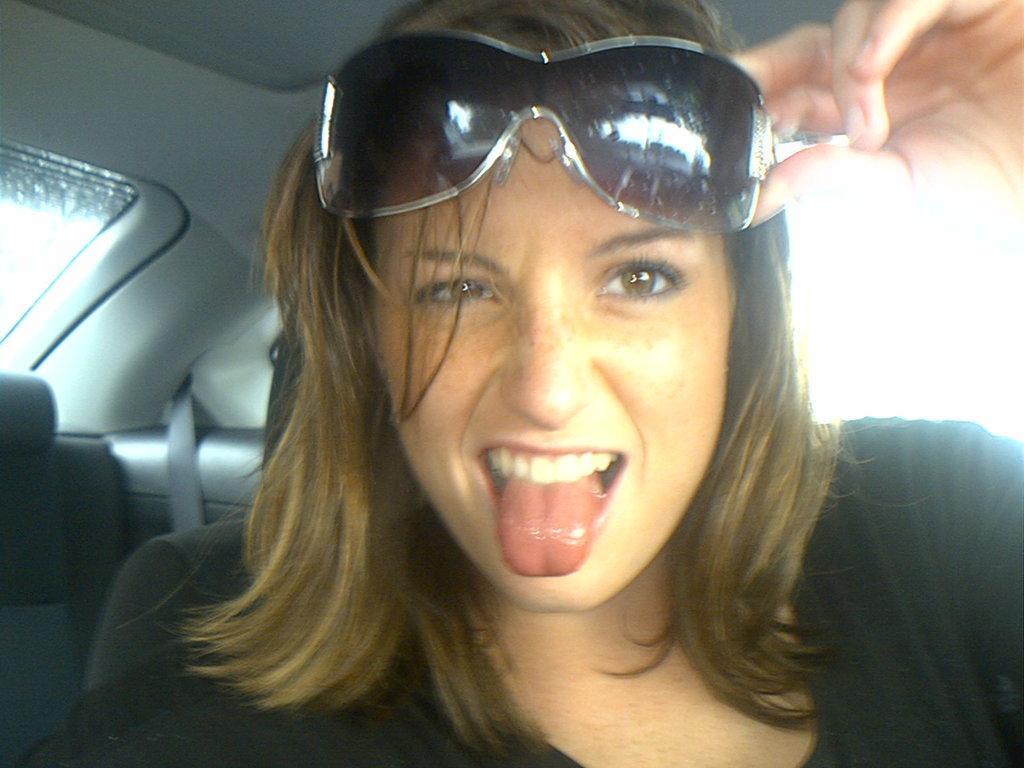Please provide a concise description of this image. The picture inside a car a woman is sitting in the seat she is wearing goggles and holding it with her hands. 